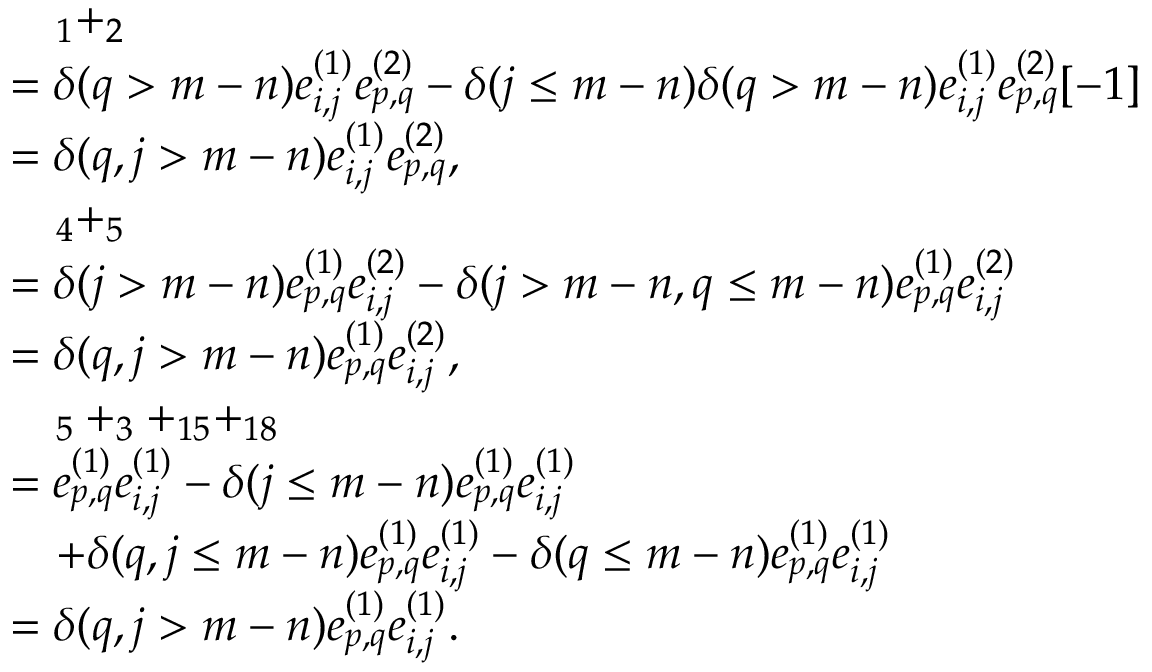Convert formula to latex. <formula><loc_0><loc_0><loc_500><loc_500>\begin{array} { r l } & { \quad _ { 1 } + _ { 2 } } \\ & { = \delta ( q > m - n ) e _ { i , j } ^ { ( 1 ) } e _ { p , q } ^ { ( 2 ) } - \delta ( j \leq m - n ) \delta ( q > m - n ) e _ { i , j } ^ { ( 1 ) } e _ { p , q } ^ { ( 2 ) } [ - 1 ] } \\ & { = \delta ( q , j > m - n ) e _ { i , j } ^ { ( 1 ) } e _ { p , q } ^ { ( 2 ) } , } \\ & { \quad _ { 4 } + _ { 5 } } \\ & { = \delta ( j > m - n ) e _ { p , q } ^ { ( 1 ) } e _ { i , j } ^ { ( 2 ) } - \delta ( j > m - n , q \leq m - n ) e _ { p , q } ^ { ( 1 ) } e _ { i , j } ^ { ( 2 ) } } \\ & { = \delta ( q , j > m - n ) e _ { p , q } ^ { ( 1 ) } e _ { i , j } ^ { ( 2 ) } , } \\ & { \quad _ { 5 } + _ { 3 } + _ { 1 5 } + _ { 1 8 } } \\ & { = e _ { p , q } ^ { ( 1 ) } e _ { i , j } ^ { ( 1 ) } - \delta ( j \leq m - n ) e _ { p , q } ^ { ( 1 ) } e _ { i , j } ^ { ( 1 ) } } \\ & { \quad + \delta ( q , j \leq m - n ) e _ { p , q } ^ { ( 1 ) } e _ { i , j } ^ { ( 1 ) } - \delta ( q \leq m - n ) e _ { p , q } ^ { ( 1 ) } e _ { i , j } ^ { ( 1 ) } } \\ & { = \delta ( q , j > m - n ) e _ { p , q } ^ { ( 1 ) } e _ { i , j } ^ { ( 1 ) } . } \end{array}</formula> 